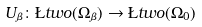Convert formula to latex. <formula><loc_0><loc_0><loc_500><loc_500>U _ { \beta } \colon \L t w o ( \Omega _ { \beta } ) \to \L t w o ( \Omega _ { 0 } )</formula> 